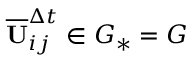<formula> <loc_0><loc_0><loc_500><loc_500>\overline { U } _ { i j } ^ { \Delta t } \in G _ { * } = G</formula> 